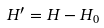<formula> <loc_0><loc_0><loc_500><loc_500>H ^ { \prime } = H - H _ { 0 }</formula> 